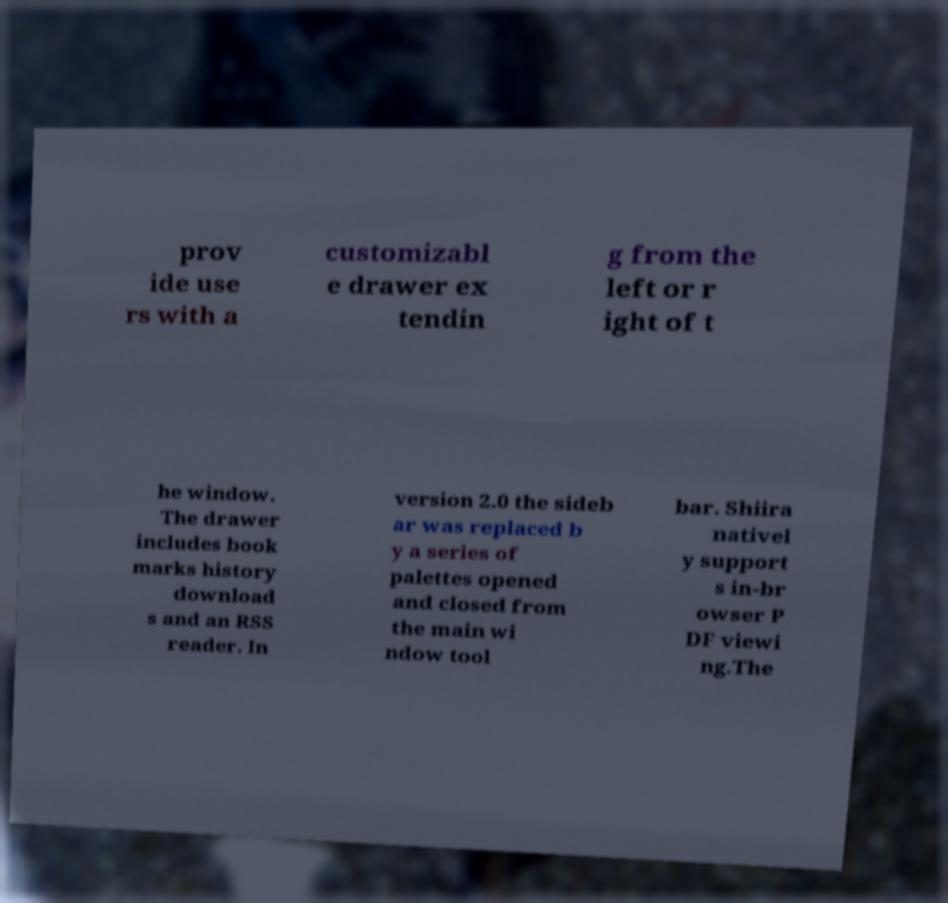Could you extract and type out the text from this image? prov ide use rs with a customizabl e drawer ex tendin g from the left or r ight of t he window. The drawer includes book marks history download s and an RSS reader. In version 2.0 the sideb ar was replaced b y a series of palettes opened and closed from the main wi ndow tool bar. Shiira nativel y support s in-br owser P DF viewi ng.The 